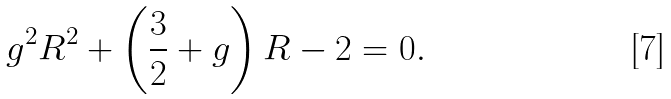<formula> <loc_0><loc_0><loc_500><loc_500>g ^ { 2 } R ^ { 2 } + \left ( \frac { 3 } { 2 } + g \right ) R - 2 = 0 .</formula> 